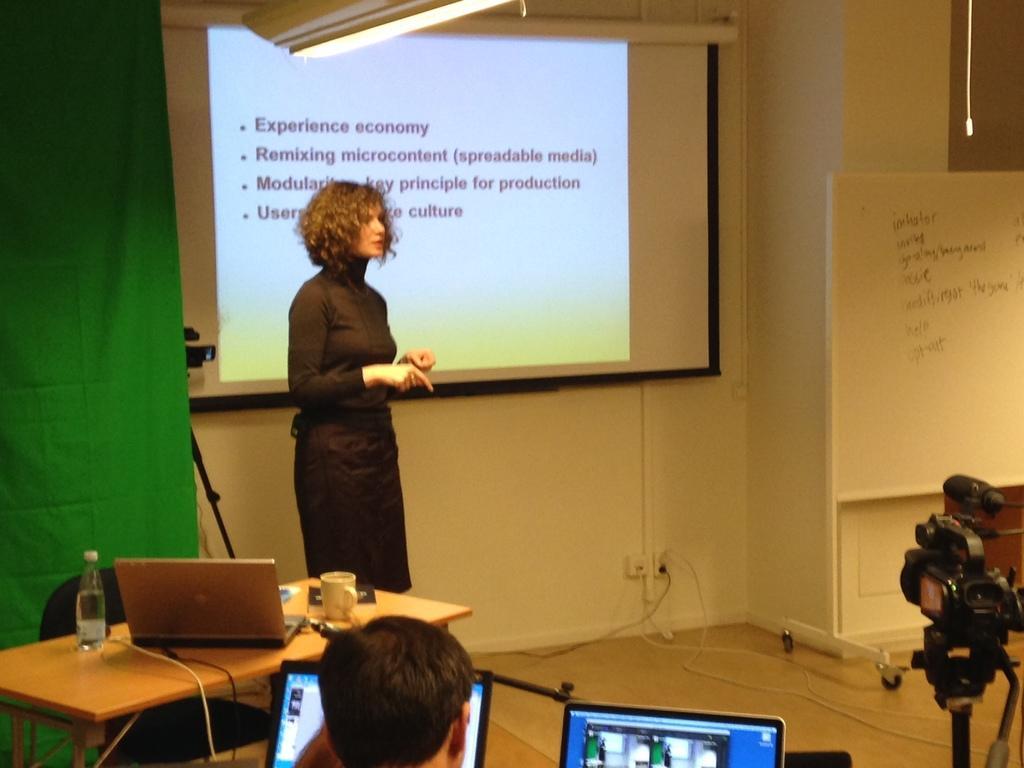Could you give a brief overview of what you see in this image? In this Image I see a woman who is standing on the floor and I see a chair and a table in front of her, I can also see few things on the table and I see that there is a person over here and there are 2 laptops and a video camera. In the background I see the board, wall, projector screen and the green cloth. 